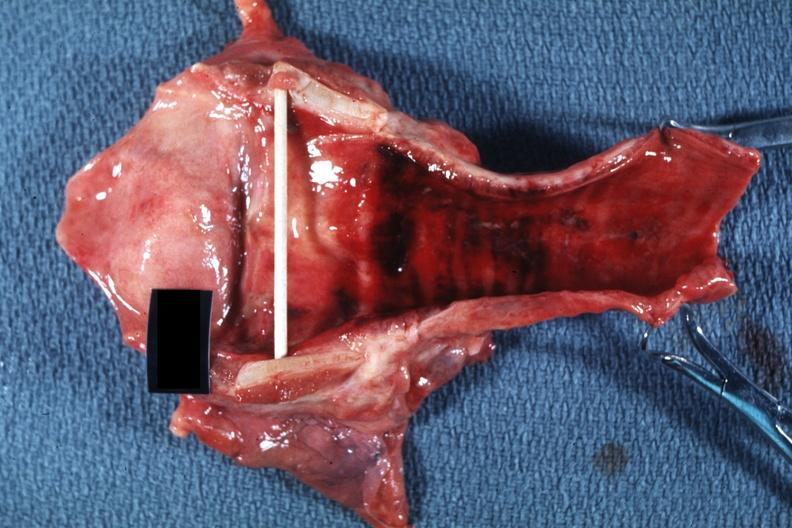s larynx present?
Answer the question using a single word or phrase. Yes 